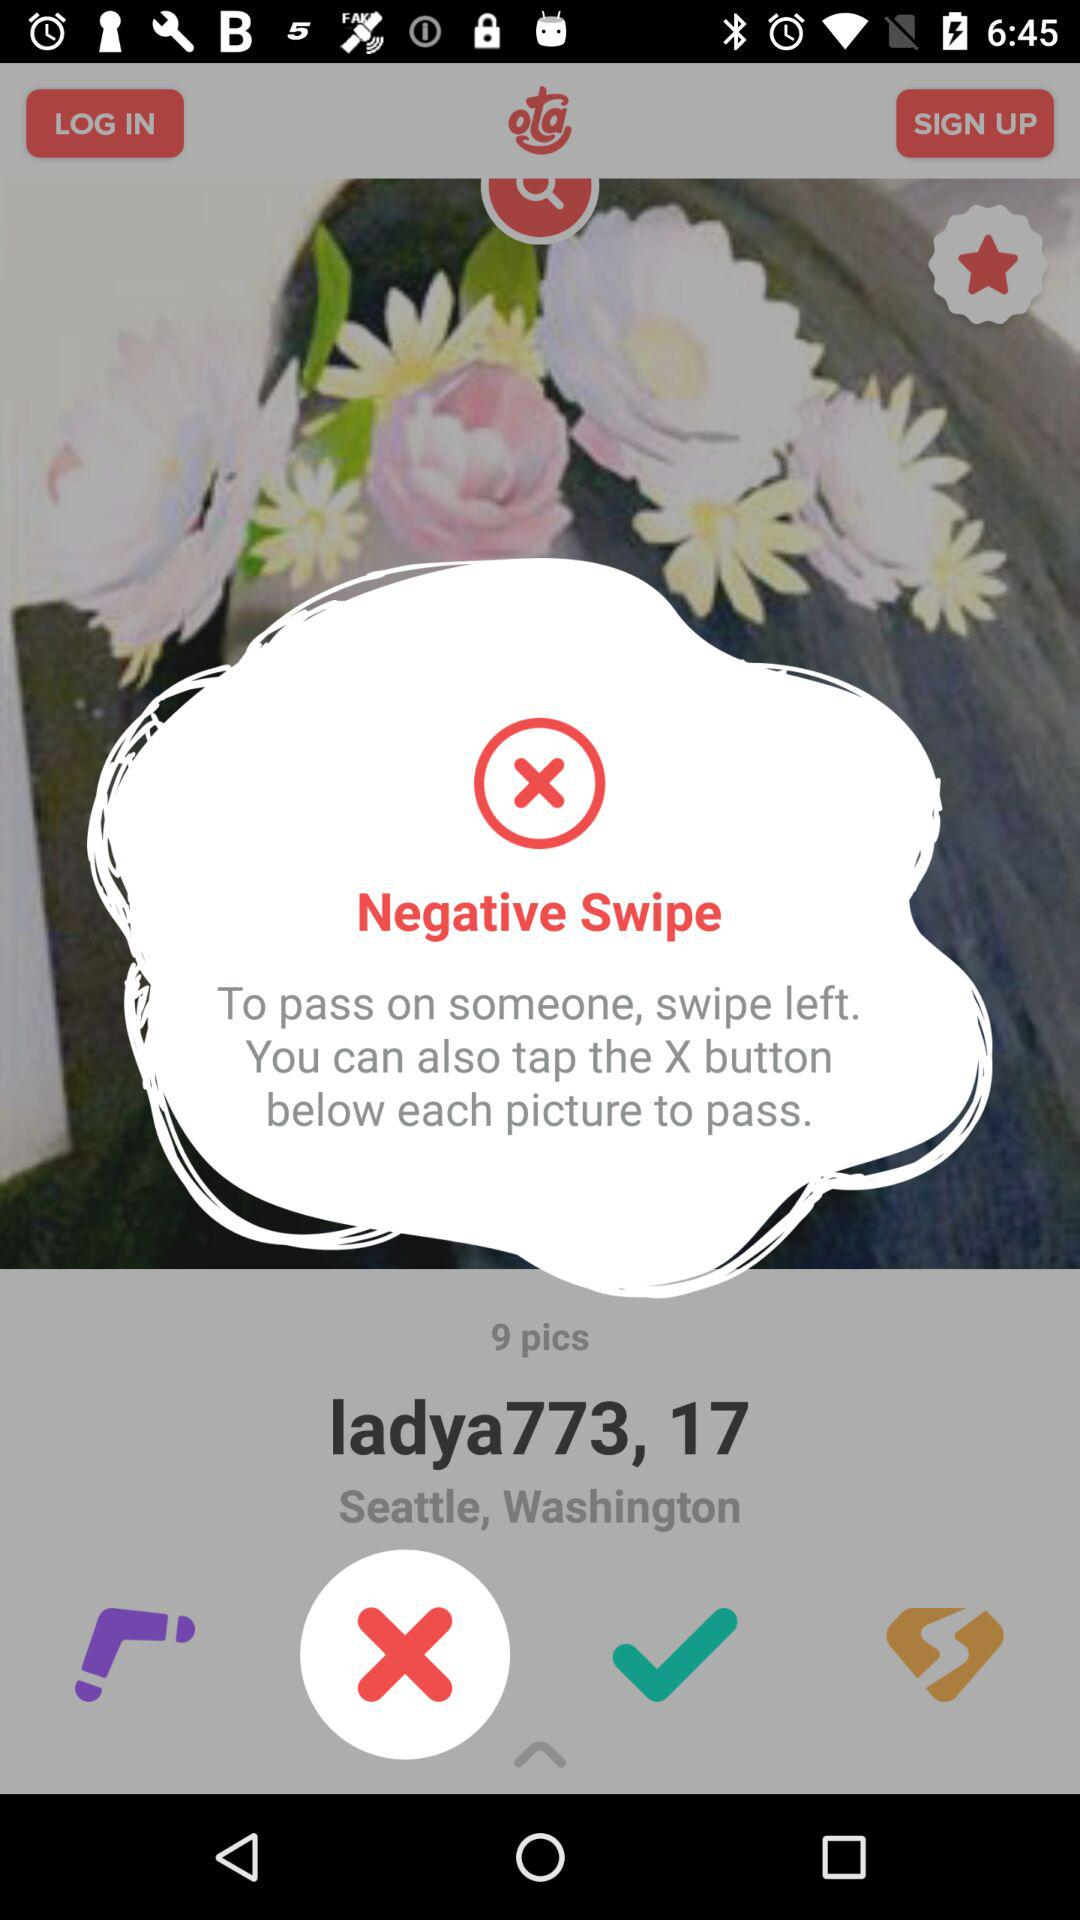How many pictures are there? There are 9 pictures. 